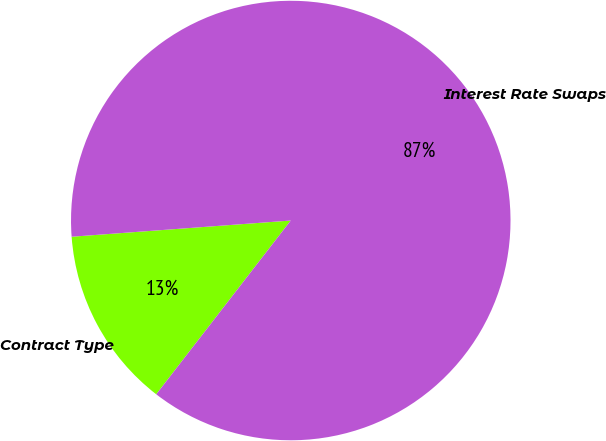<chart> <loc_0><loc_0><loc_500><loc_500><pie_chart><fcel>Contract Type<fcel>Interest Rate Swaps<nl><fcel>13.34%<fcel>86.66%<nl></chart> 